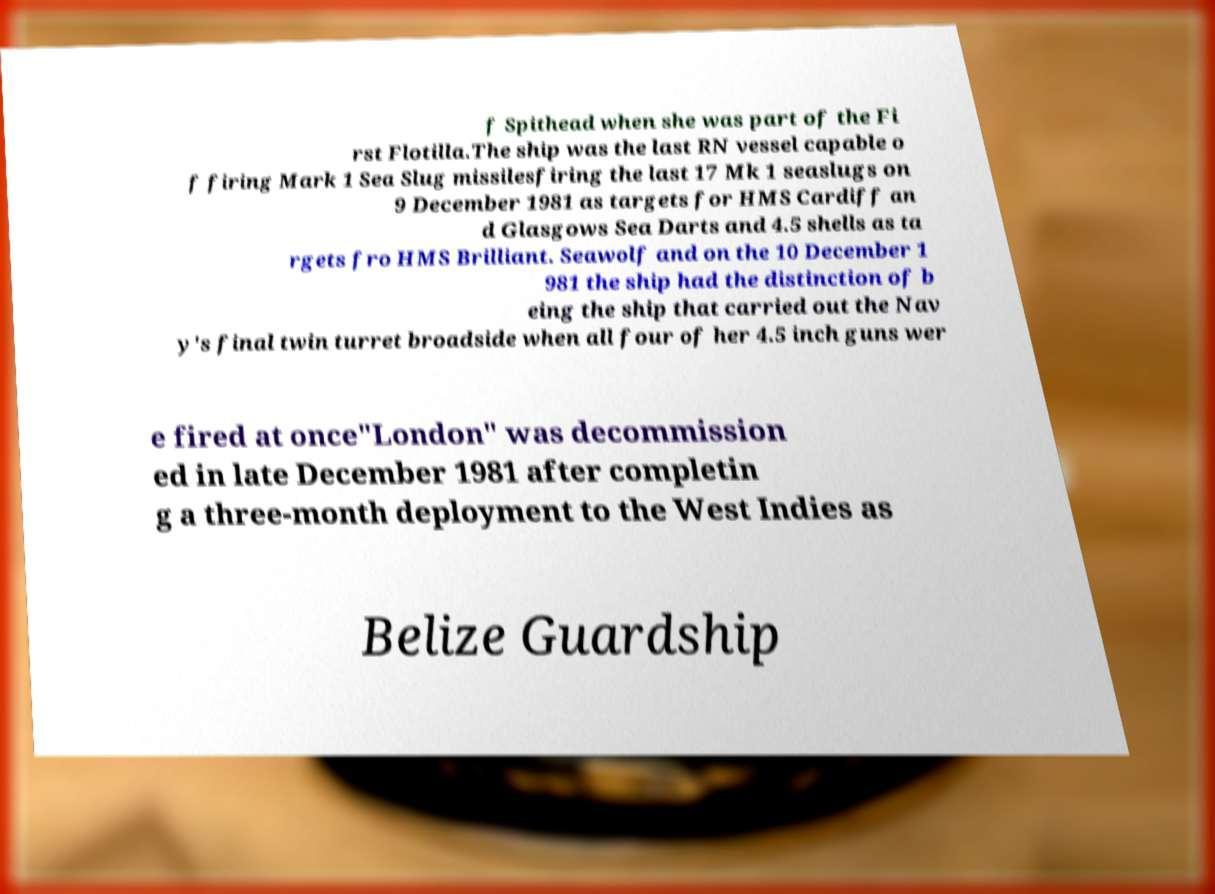Please read and relay the text visible in this image. What does it say? f Spithead when she was part of the Fi rst Flotilla.The ship was the last RN vessel capable o f firing Mark 1 Sea Slug missilesfiring the last 17 Mk 1 seaslugs on 9 December 1981 as targets for HMS Cardiff an d Glasgows Sea Darts and 4.5 shells as ta rgets fro HMS Brilliant. Seawolf and on the 10 December 1 981 the ship had the distinction of b eing the ship that carried out the Nav y's final twin turret broadside when all four of her 4.5 inch guns wer e fired at once"London" was decommission ed in late December 1981 after completin g a three-month deployment to the West Indies as Belize Guardship 